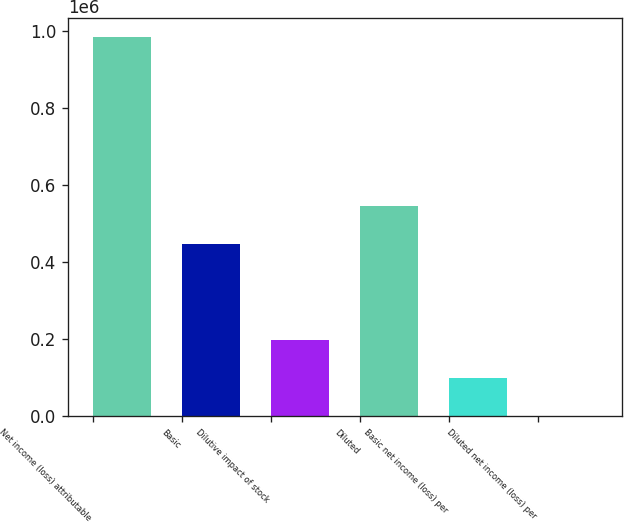<chart> <loc_0><loc_0><loc_500><loc_500><bar_chart><fcel>Net income (loss) attributable<fcel>Basic<fcel>Dilutive impact of stock<fcel>Diluted<fcel>Basic net income (loss) per<fcel>Diluted net income (loss) per<nl><fcel>984729<fcel>445865<fcel>196948<fcel>544338<fcel>98474.9<fcel>2.2<nl></chart> 